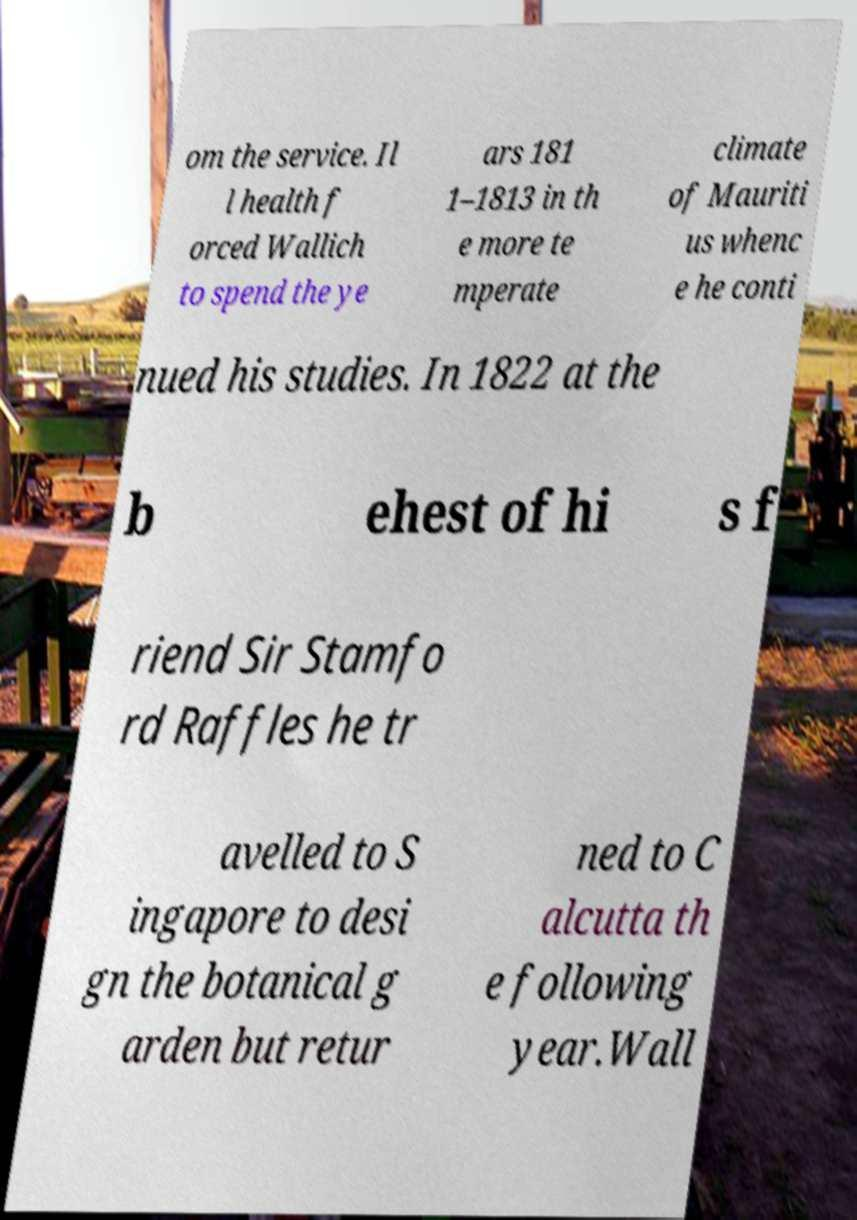I need the written content from this picture converted into text. Can you do that? om the service. Il l health f orced Wallich to spend the ye ars 181 1–1813 in th e more te mperate climate of Mauriti us whenc e he conti nued his studies. In 1822 at the b ehest of hi s f riend Sir Stamfo rd Raffles he tr avelled to S ingapore to desi gn the botanical g arden but retur ned to C alcutta th e following year.Wall 